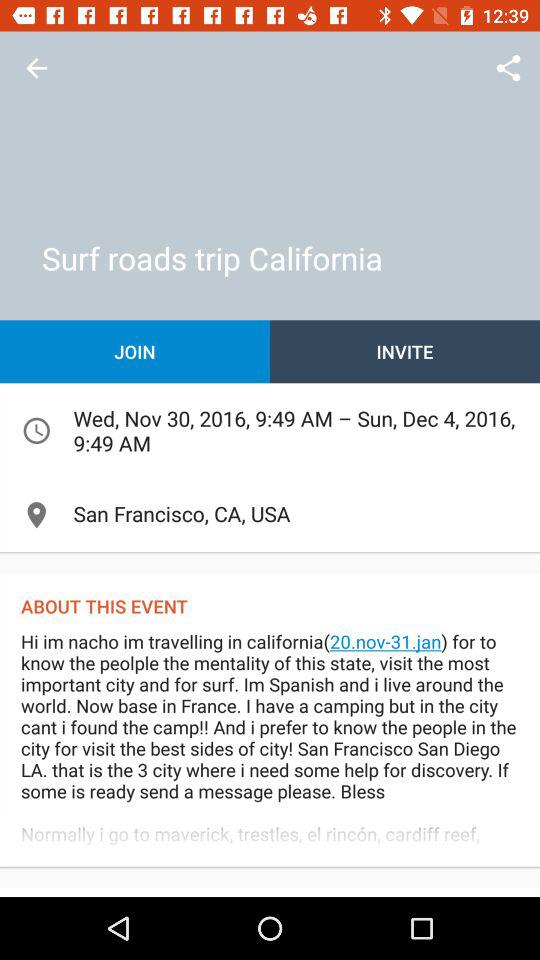How many days does this event last?
Answer the question using a single word or phrase. 4 